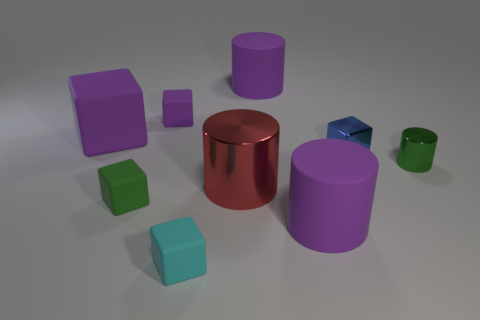Are there the same number of blue blocks that are to the right of the big rubber block and cubes that are on the right side of the tiny green block?
Give a very brief answer. No. Is the big purple cylinder behind the large purple cube made of the same material as the green object that is in front of the tiny green cylinder?
Provide a succinct answer. Yes. What number of other objects are there of the same size as the green rubber cube?
Offer a terse response. 4. What number of objects are cylinders or large things behind the big purple block?
Keep it short and to the point. 4. Are there an equal number of small green rubber things that are on the right side of the large purple cube and large red metal blocks?
Make the answer very short. No. What is the shape of the tiny purple thing that is the same material as the large purple block?
Make the answer very short. Cube. Are there any other large blocks of the same color as the metal block?
Provide a short and direct response. No. What number of shiny objects are tiny red cylinders or large purple cubes?
Provide a short and direct response. 0. How many cylinders are in front of the tiny green thing left of the large red metal thing?
Make the answer very short. 1. What number of small things are made of the same material as the big red cylinder?
Make the answer very short. 2. 